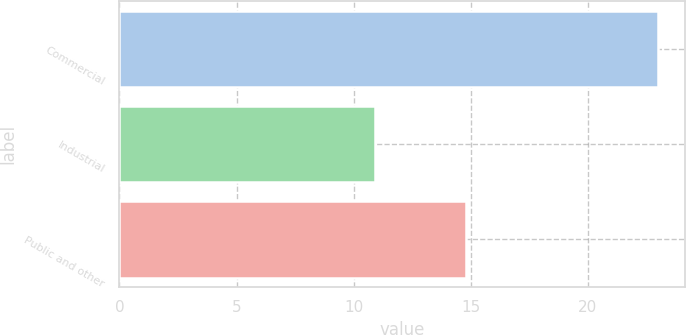<chart> <loc_0><loc_0><loc_500><loc_500><bar_chart><fcel>Commercial<fcel>Industrial<fcel>Public and other<nl><fcel>23<fcel>10.9<fcel>14.8<nl></chart> 